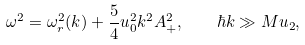Convert formula to latex. <formula><loc_0><loc_0><loc_500><loc_500>\omega ^ { 2 } = \omega _ { r } ^ { 2 } ( k ) + \frac { 5 } { 4 } u _ { 0 } ^ { 2 } k ^ { 2 } A _ { + } ^ { 2 } , \quad \hbar { k } \gg M u _ { 2 } ,</formula> 